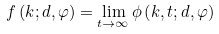Convert formula to latex. <formula><loc_0><loc_0><loc_500><loc_500>f \left ( k ; d , \varphi \right ) = \lim _ { t \rightarrow \infty } \phi \left ( k , t ; d , \varphi \right )</formula> 